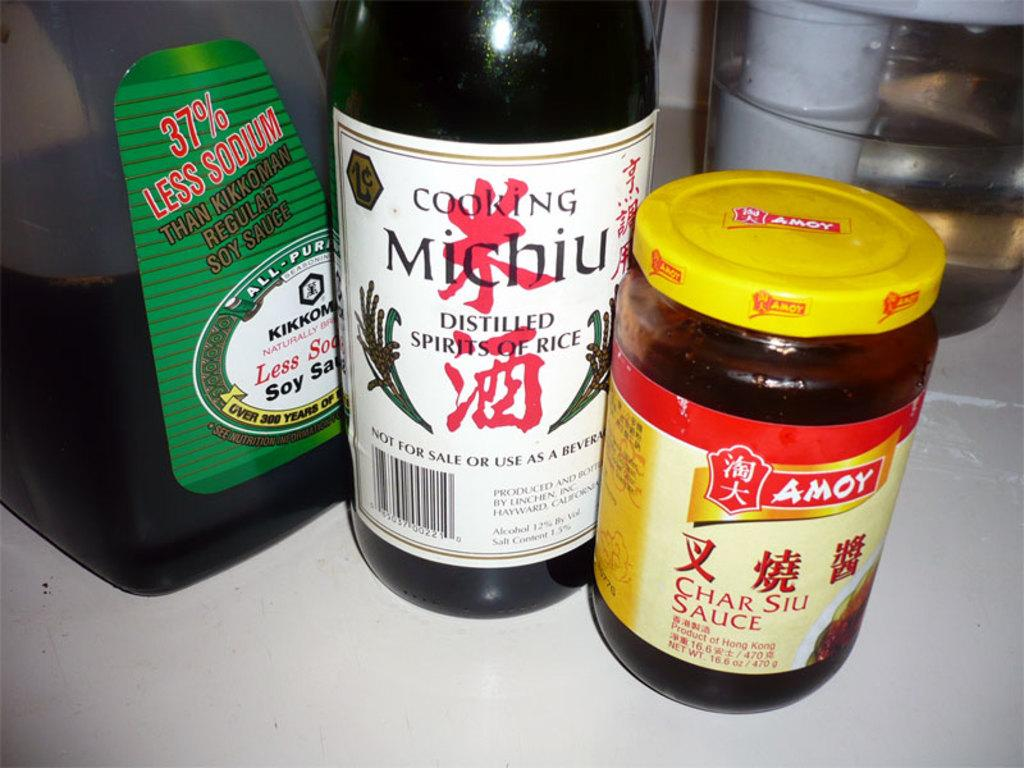Provide a one-sentence caption for the provided image. Char Siu Sauce, soy sauce and Michiu all sit on the counter. 